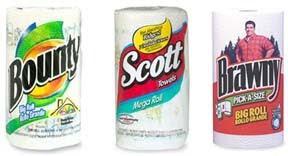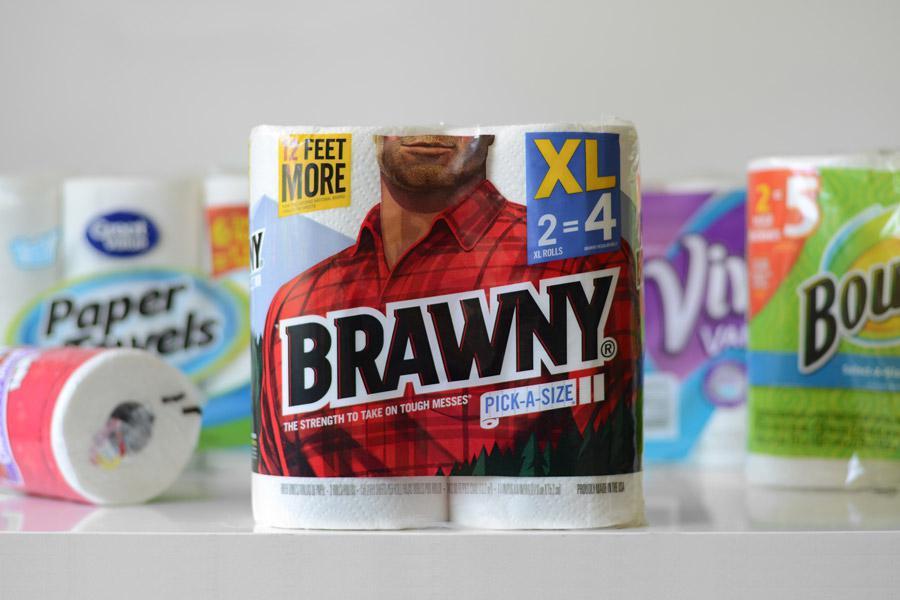The first image is the image on the left, the second image is the image on the right. Examine the images to the left and right. Is the description "Each image shows a single upright roll of paper towels, and the left and right rolls do not have identical packaging." accurate? Answer yes or no. No. The first image is the image on the left, the second image is the image on the right. Considering the images on both sides, is "There are exactly two rolls of paper towels." valid? Answer yes or no. No. 